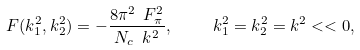Convert formula to latex. <formula><loc_0><loc_0><loc_500><loc_500>F ( k ^ { 2 } _ { 1 } , k ^ { 2 } _ { 2 } ) = - \frac { 8 \pi ^ { 2 } \ F ^ { 2 } _ { \pi } } { N _ { c } \ k ^ { 2 } } , \quad \ k _ { 1 } ^ { 2 } = k _ { 2 } ^ { 2 } = k ^ { 2 } < < 0 ,</formula> 